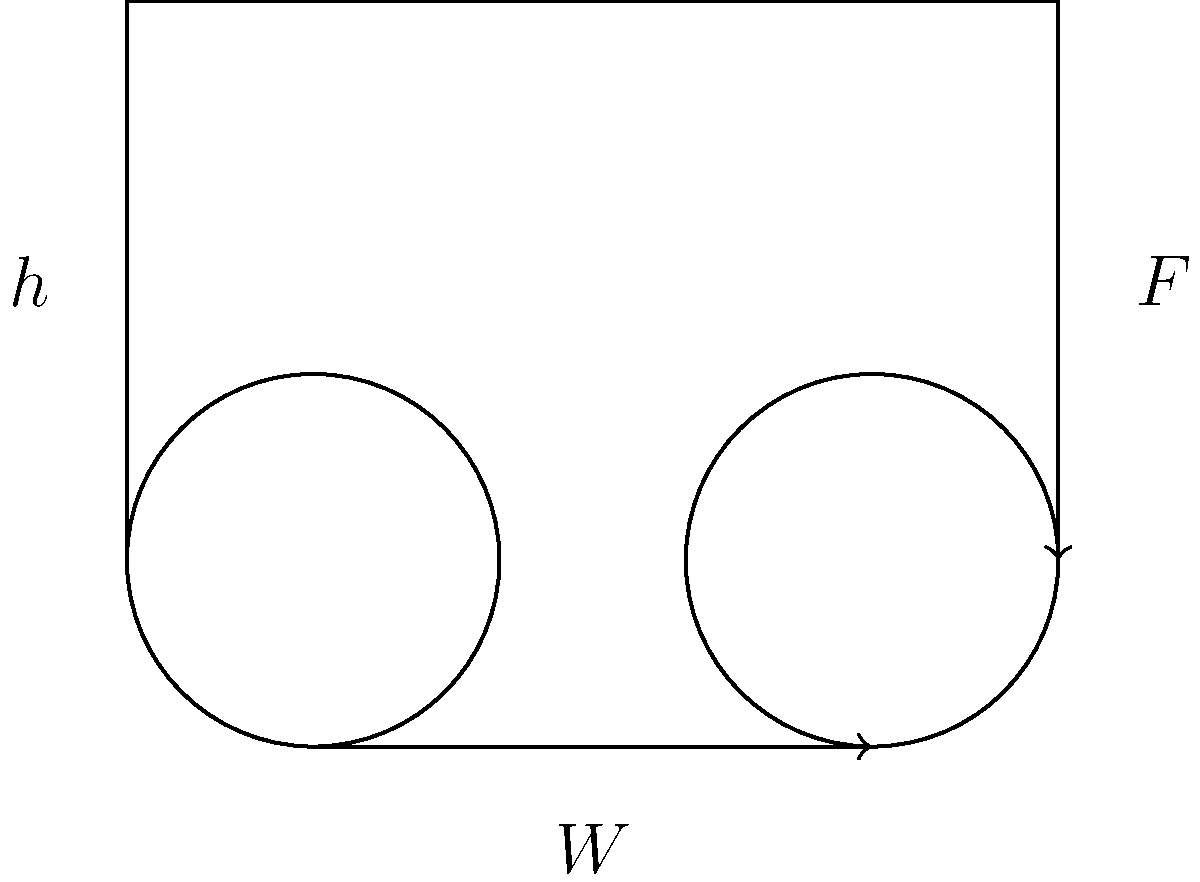As the law firm manager, you need to move a heavy filing cabinet to a new office. You decide to use a simple pulley system to lift it. The system consists of two pulleys, one fixed and one movable. If the effort force (F) required to lift the cabinet is 500 N and the weight (W) of the cabinet is 900 N, calculate the efficiency of this pulley system. Assume the height (h) the cabinet needs to be lifted is 2 meters. To calculate the efficiency of the pulley system, we need to follow these steps:

1. Calculate the ideal mechanical advantage (IMA):
   For a system with one fixed and one movable pulley, IMA = 2

2. Calculate the actual mechanical advantage (AMA):
   $AMA = \frac{W}{F} = \frac{900 N}{500 N} = 1.8$

3. Calculate the efficiency:
   Efficiency = $\frac{AMA}{IMA} \times 100\%$
   
   $\text{Efficiency} = \frac{1.8}{2} \times 100\% = 90\%$

4. Verify using work done:
   Work input = Force × Distance
   $W_{in} = F \times 2h = 500 N \times 4 m = 2000 J$
   (Note: The force moves twice the distance the load moves)

   Work output = Weight × Height
   $W_{out} = W \times h = 900 N \times 2 m = 1800 J$

   Efficiency = $\frac{W_{out}}{W_{in}} \times 100\% = \frac{1800 J}{2000 J} \times 100\% = 90\%$

This confirms our calculated efficiency.
Answer: 90% 